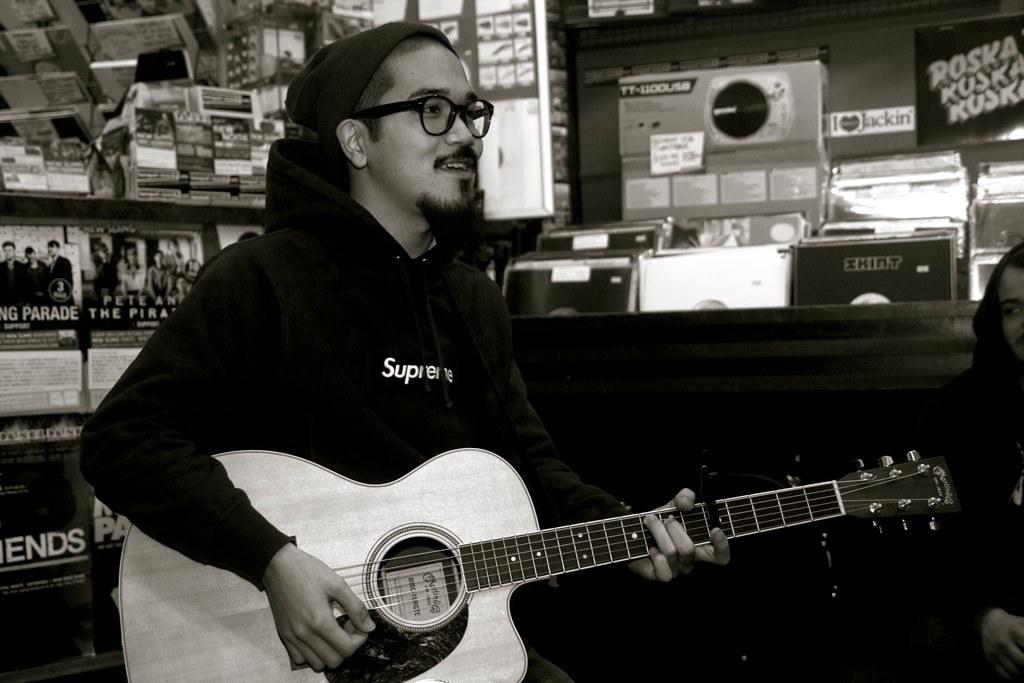What is the person in the image doing? The person is playing a guitar. Can you describe the person's attire? The person is wearing a cap and glasses. What is the person's posture in the image? The person is sitting. What can be seen in the background of the image? There are posters and a wall in the background. What type of waves can be seen crashing against the tank in the image? There is no tank or waves present in the image; it features a person playing a guitar with a background of posters and a wall. 